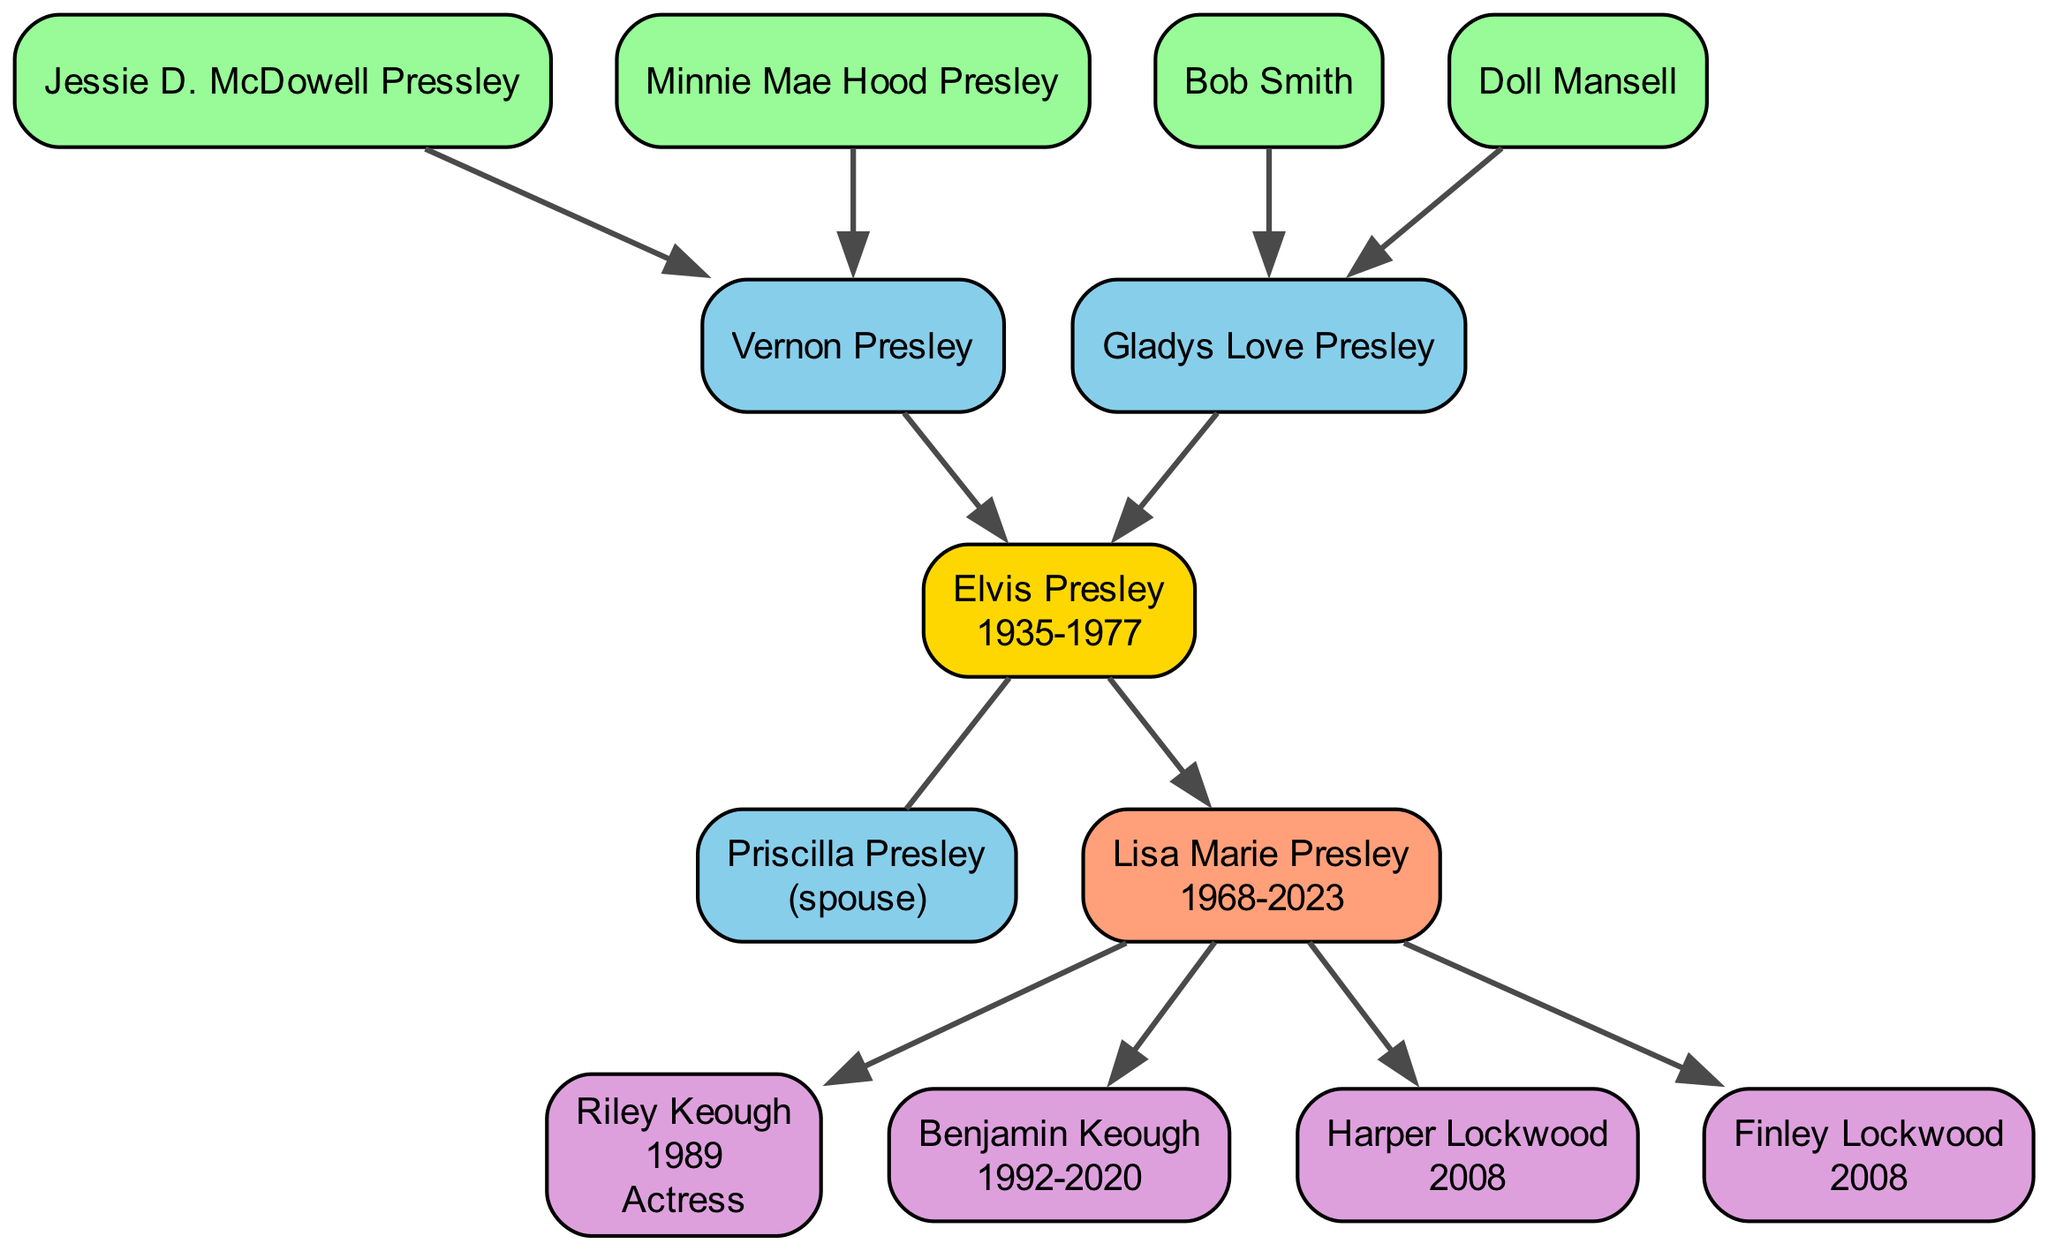What year was Elvis Presley born? The diagram states that Elvis Presley was born in the year 1935. This information is located directly in his node.
Answer: 1935 Who are Elvis Presley's parents? The diagram indicates that Elvis Presley's parents are Vernon Presley and Gladys Love Presley. Their names are listed as direct connections to Elvis in the family tree.
Answer: Vernon Presley and Gladys Love Presley How many children did Elvis Presley have? According to the diagram, Elvis Presley has one child, Lisa Marie Presley, shown as a direct descendant.
Answer: 1 Who is Lisa Marie Presley's child that was born in 2008? The diagram shows two children born in 2008 under Lisa Marie Presley: Harper Lockwood and Finley Lockwood. Since the question specifies a single child, both names are valid, but only one can be listed.
Answer: Harper Lockwood What is the occupation of Riley Keough? In the diagram, it notes that Riley Keough is an actress, which is stated alongside her name in the diagram.
Answer: Actress Which grandparent is linked to Elvis Presley through Gladys Love Presley? The diagram indicates that Minnie Mae Hood Presley is the maternal grandparent of Elvis, linked through Gladys Love Presley. This information can be derived from the structure of the family tree where the grandparents are connected to their respective children.
Answer: Minnie Mae Hood Presley How many grandchildren does Lisa Marie Presley have? The diagram shows that Lisa Marie Presley has four grandchildren: Riley Keough, Benjamin Keough, Harper Lockwood, and Finley Lockwood. This total is found by counting all the children listed under Lisa Marie in the family tree.
Answer: 4 Who was Elvis Presley's spouse? The diagram cites Priscilla Presley as the spouse of Elvis Presley, represented as a direct connection. This relationship is depicted clearly in the tree, showing their marital status.
Answer: Priscilla Presley When did Benjamin Keough die? The diagram provides that Benjamin Keough was born in 1992 and died in 2020, which is stated directly in the section describing him.
Answer: 2020 